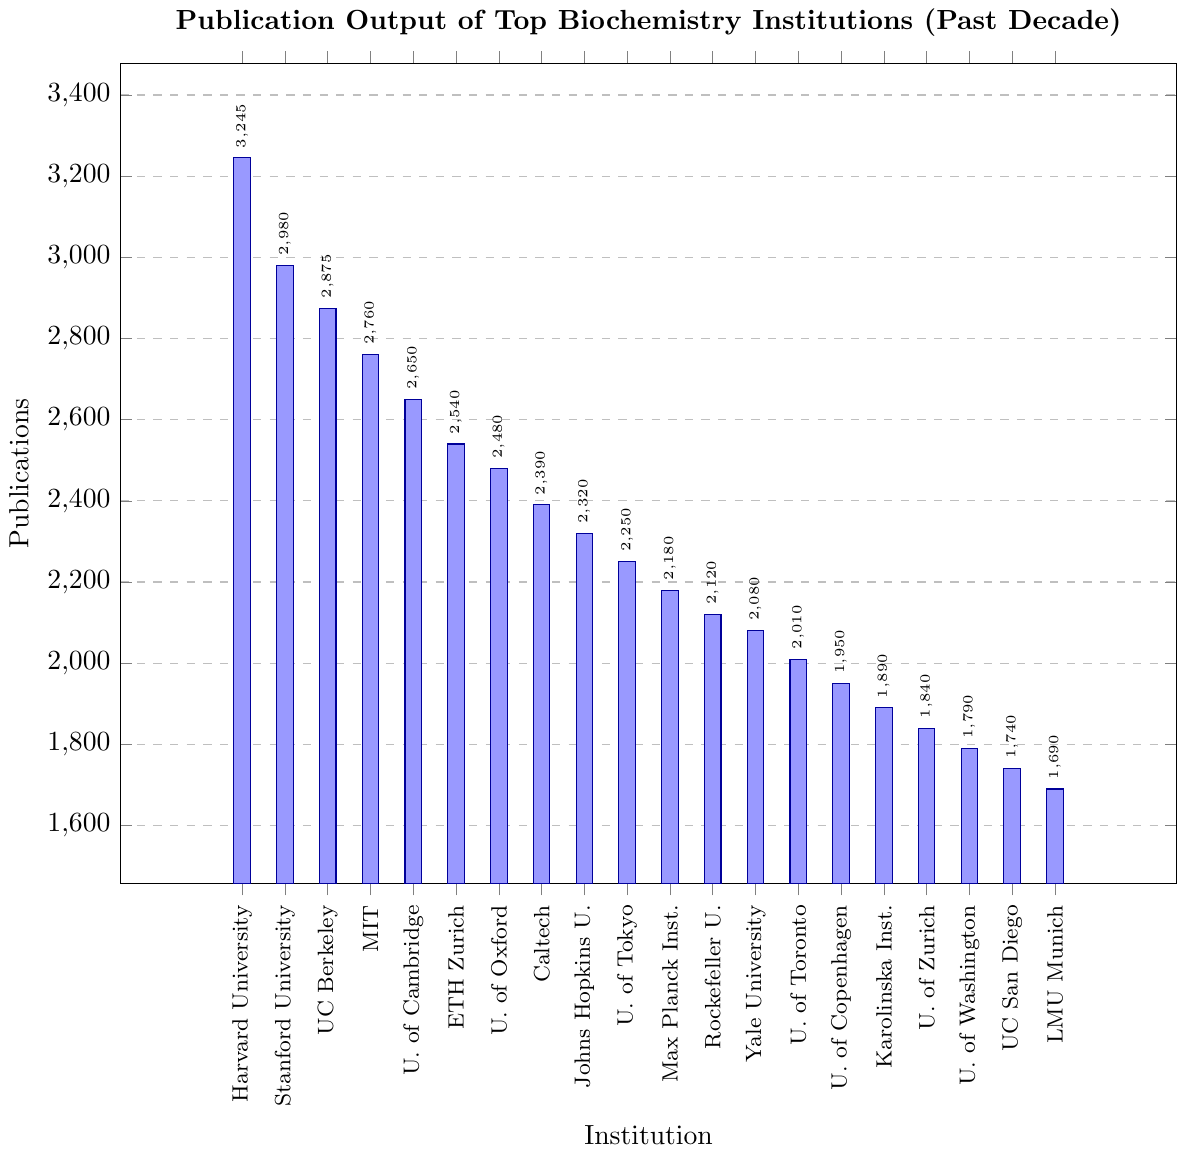Which institution has the highest publication output? By examining the height of the bars, we can see that Harvard University has the tallest bar, indicating it has the highest publication output among the listed institutions.
Answer: Harvard University What is the difference in the number of publications between Harvard University and MIT? Harvard University has 3245 publications, and MIT has 2760 publications. Subtracting the two gives 3245 - 2760 = 485.
Answer: 485 Which institutions have publication outputs greater than 2500? The institutions with bars higher than the 2500 mark on the y-axis are Harvard University, Stanford University, University of California Berkeley, MIT, and University of Cambridge.
Answer: Harvard University, Stanford University, University of California Berkeley, MIT, University of Cambridge How many institutions have a publication output between 2000 and 3000? The bars that fall within the range of 2000 to 3000 publications include Stanford University, University of California Berkeley, MIT, University of Cambridge, ETH Zurich, University of Oxford, California Institute of Technology, and Johns Hopkins University. Counting these gives a total of 8 institutions.
Answer: 8 What is the average number of publications for the top three institutions? The top three institutions by publication output are Harvard University (3245), Stanford University (2980), and University of California Berkeley (2875). The average is calculated by (3245 + 2980 + 2875) / 3 = 3033.33.
Answer: 3033.33 Between which two institutions is the smallest difference in publication output found? By examining the heights of the bars and calculating the differences, the smallest difference is between ETH Zurich (2540) and the University of Oxford (2480), with a difference of 60.
Answer: ETH Zurich and University of Oxford What is the total number of publications for all institutions combined? Summing up the publication numbers for all institutions: 3245 + 2980 + 2875 + 2760 + 2650 + 2540 + 2480 + 2390 + 2320 + 2250 + 2180 + 2120 + 2080 + 2010 + 1950 + 1890 + 1840 + 1790 + 1740 + 1690 = 52340.
Answer: 52340 Which institution ranks fifth in publication output? By ordering the institutions by the height of the bars, the fifth institution is the University of Cambridge with 2650 publications.
Answer: University of Cambridge What is the publication output difference between the institution with the lowest and highest output? The institution with the highest publication output is Harvard University (3245), and the institution with the lowest publication output is Ludwig Maximilian University of Munich (1690). The difference is 3245 - 1690 = 1555.
Answer: 1555 